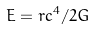<formula> <loc_0><loc_0><loc_500><loc_500>E = r c ^ { 4 } / 2 G</formula> 